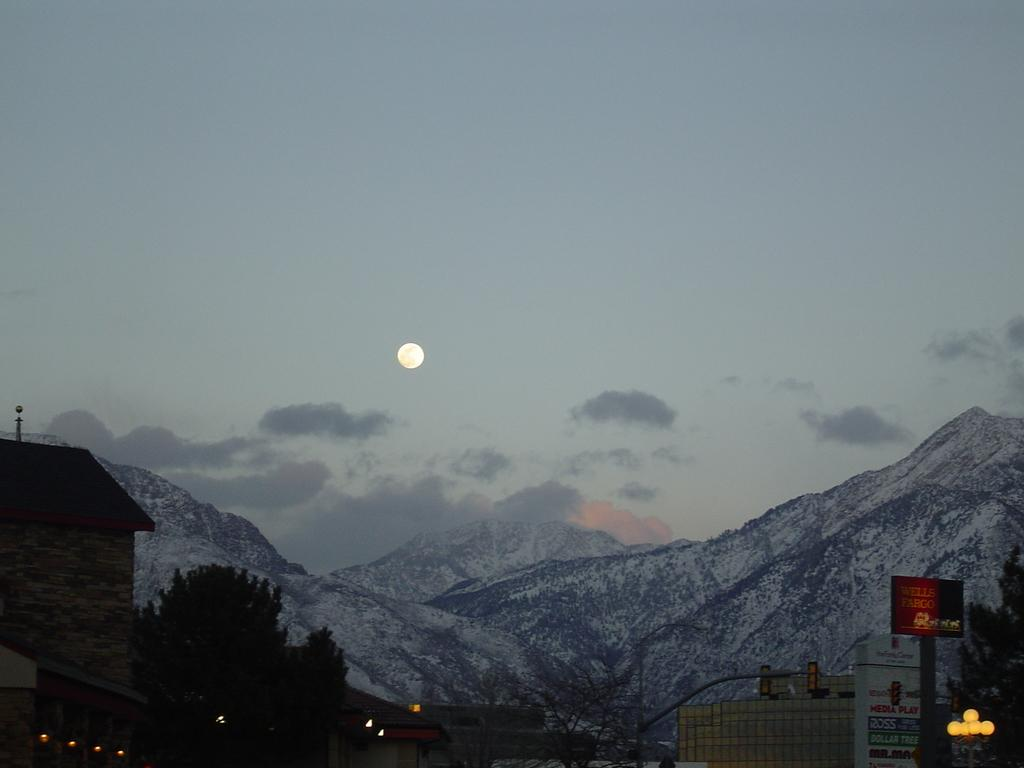What type of structure is in the picture? There is a house in the picture. What other natural elements can be seen in the picture? There are trees in the picture. What can be seen in the background of the picture? There are mountains with snow and a sky visible in the background of the picture. What is the condition of the sky in the picture? Clouds are present in the sky, and the moon is visible. What type of box can be heard making noise in the image? There is no box present in the image, and therefore no noise can be heard. What type of friction is occurring between the trees and the mountains in the image? There is no indication of friction between the trees and the mountains in the image; they are separate elements in the scene. 